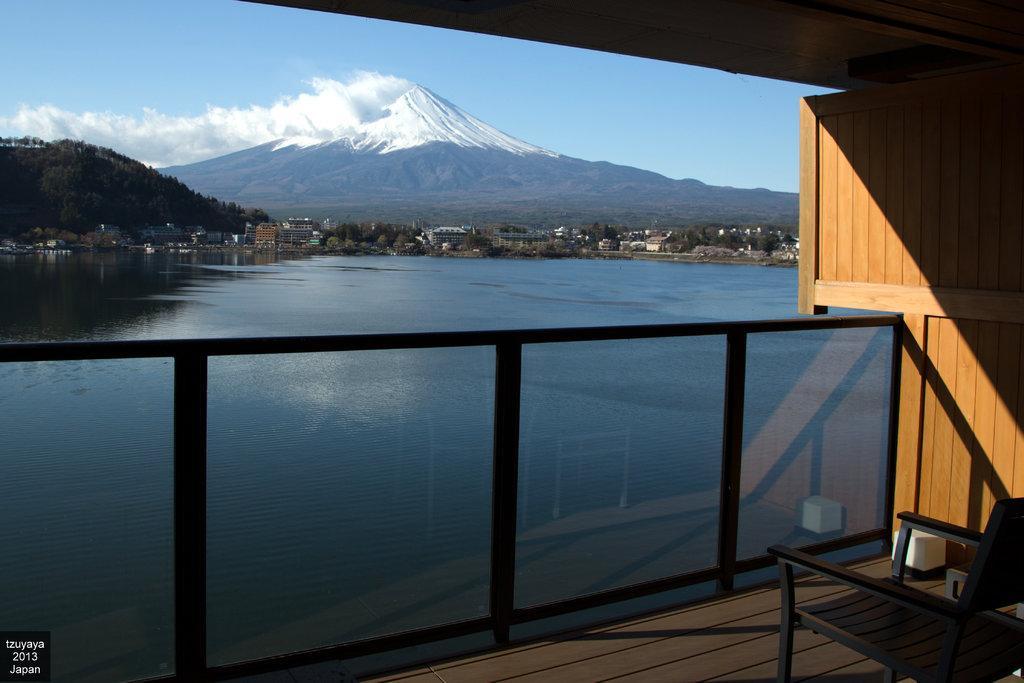Describe this image in one or two sentences. In the right bottom of the picture, we see a black chair and a wooden wall. Beside that, we see a glass railing. We see water and this water might be in the river. In the background, there are trees, buildings and hills. At the top of the picture, we see the sky. 